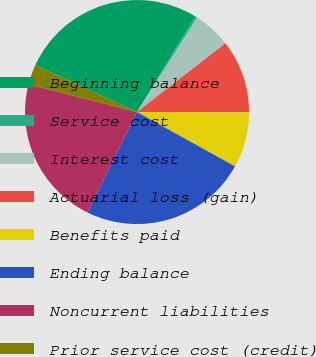Convert chart. <chart><loc_0><loc_0><loc_500><loc_500><pie_chart><fcel>Beginning balance<fcel>Service cost<fcel>Interest cost<fcel>Actuarial loss (gain)<fcel>Benefits paid<fcel>Ending balance<fcel>Noncurrent liabilities<fcel>Prior service cost (credit)<nl><fcel>26.8%<fcel>0.33%<fcel>5.45%<fcel>10.57%<fcel>8.01%<fcel>24.24%<fcel>21.68%<fcel>2.89%<nl></chart> 